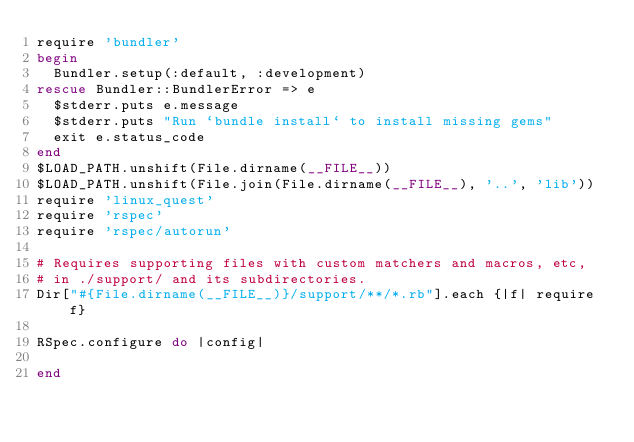<code> <loc_0><loc_0><loc_500><loc_500><_Ruby_>require 'bundler'
begin
  Bundler.setup(:default, :development)
rescue Bundler::BundlerError => e
  $stderr.puts e.message
  $stderr.puts "Run `bundle install` to install missing gems"
  exit e.status_code
end
$LOAD_PATH.unshift(File.dirname(__FILE__))
$LOAD_PATH.unshift(File.join(File.dirname(__FILE__), '..', 'lib'))
require 'linux_quest'
require 'rspec'
require 'rspec/autorun'

# Requires supporting files with custom matchers and macros, etc,
# in ./support/ and its subdirectories.
Dir["#{File.dirname(__FILE__)}/support/**/*.rb"].each {|f| require f}

RSpec.configure do |config|

end</code> 